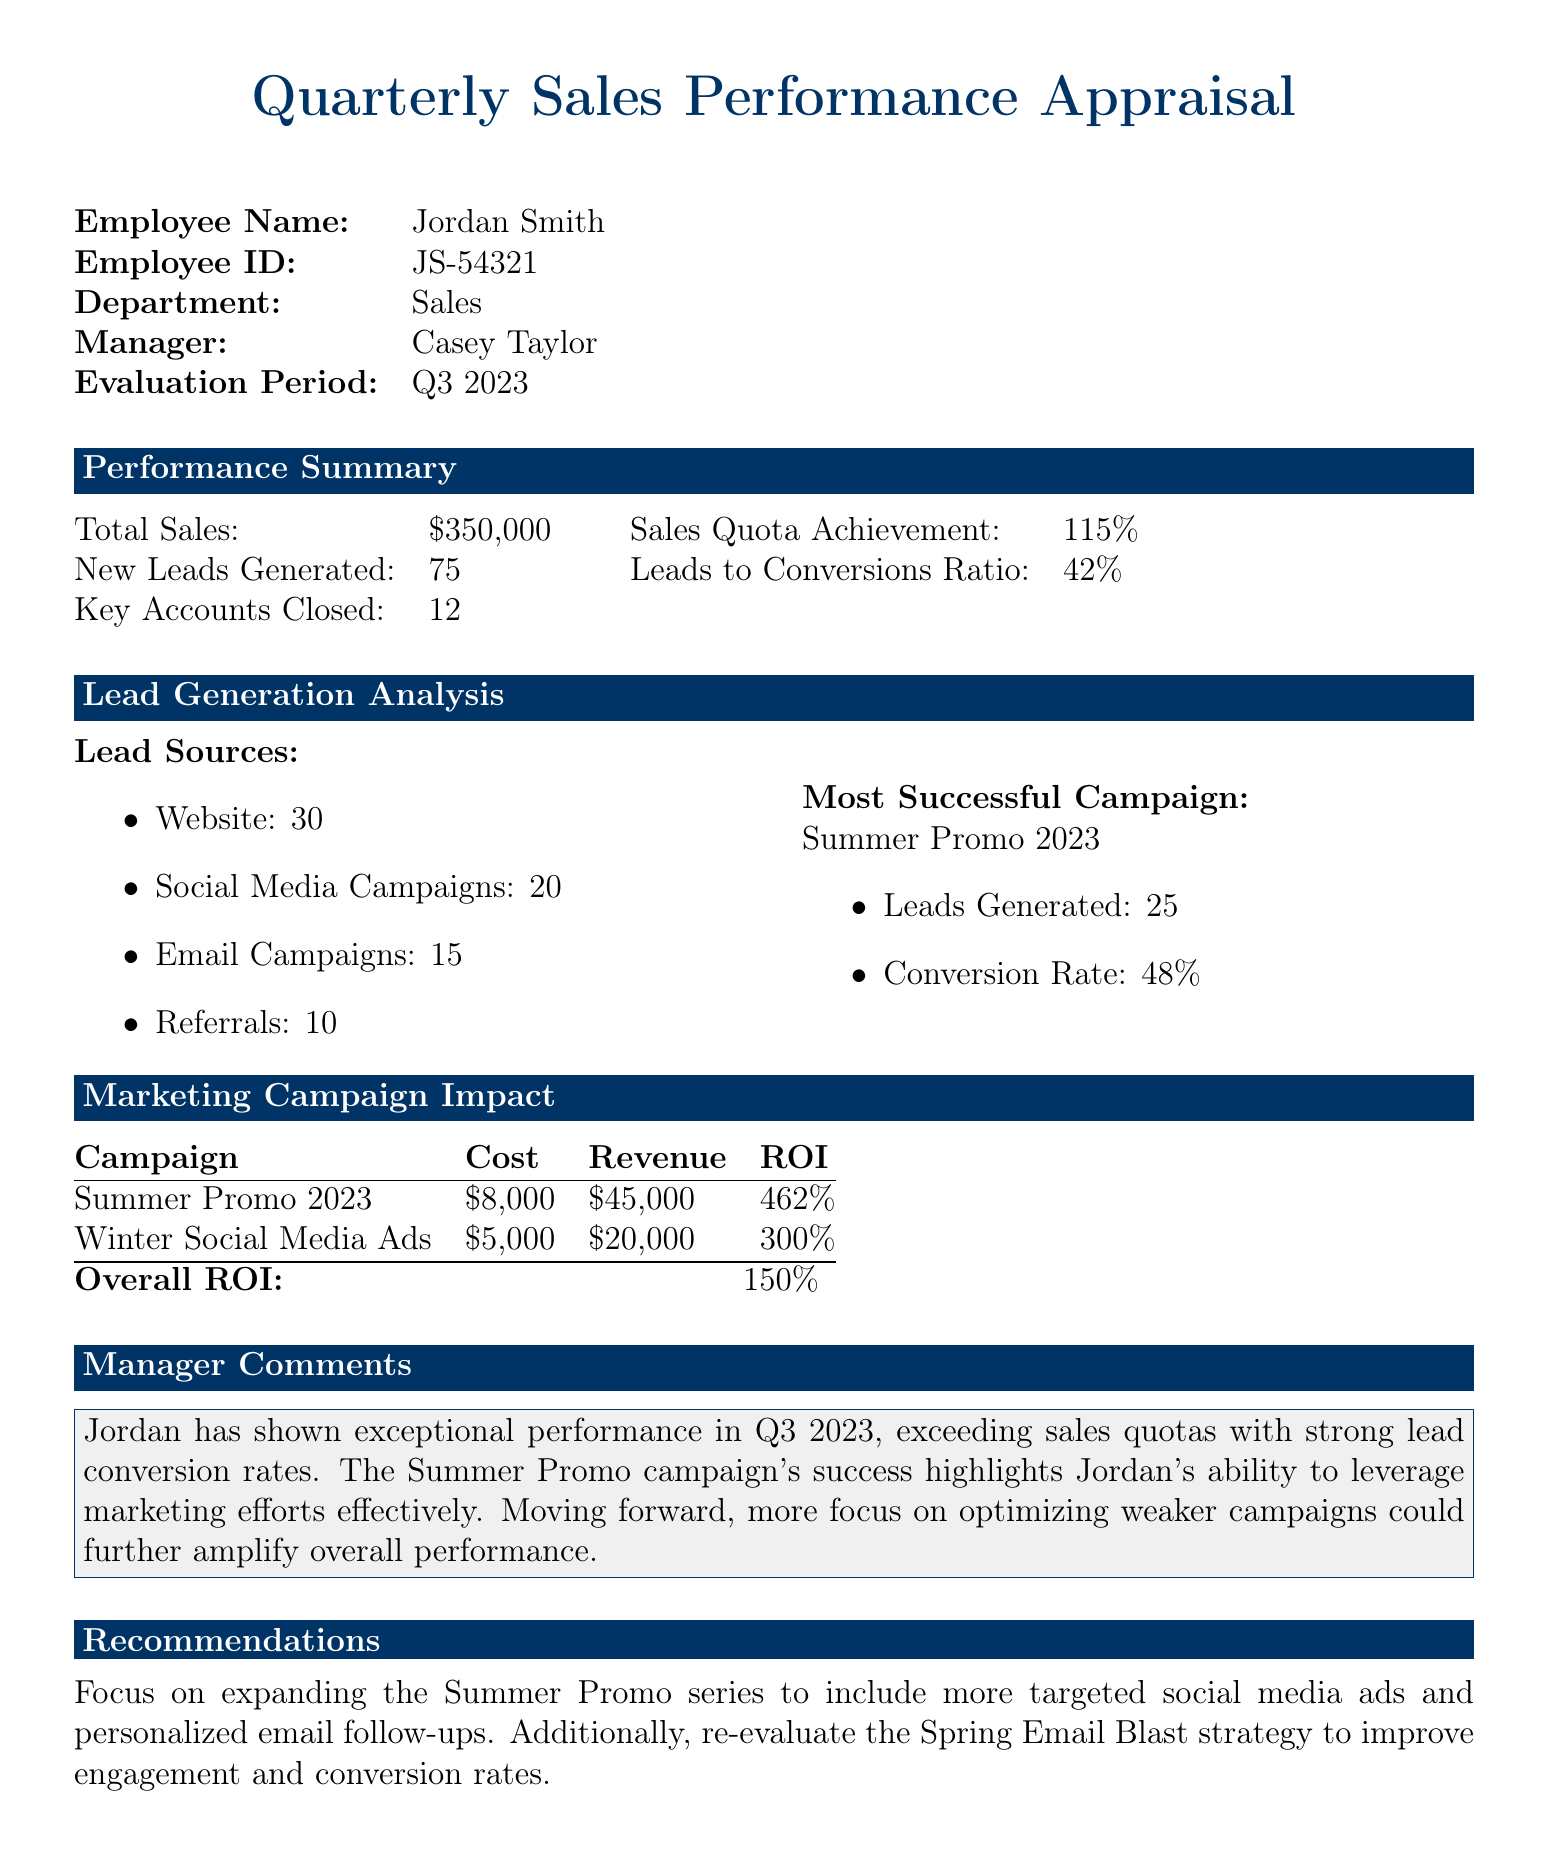What was the total sales amount for Q3 2023? The total sales amount is provided in the performance summary section of the document.
Answer: $350,000 How many new leads were generated? The number of new leads generated is noted directly in the performance summary section.
Answer: 75 What is the conversion rate from leads to sales? The conversion rate is calculated from the leads to conversions ratio stated in the performance summary.
Answer: 42% Which marketing campaign generated the most leads? The campaign that generated the most leads is highlighted under the lead generation analysis section.
Answer: Summer Promo 2023 What was the ROI of the Winter Social Media Ads campaign? ROI for the Winter Social Media Ads is listed in the marketing campaign impact section.
Answer: 300% How many key accounts were closed? The number of key accounts closed is mentioned in the performance summary section.
Answer: 12 What was the overall ROI for all campaigns? Overall ROI is calculated and indicated in the marketing campaign impact section.
Answer: 150% What did the manager suggest for improving future campaigns? The manager's comment includes recommendations for future campaign strategies, highlighting specific areas to focus on.
Answer: Optimize weaker campaigns 